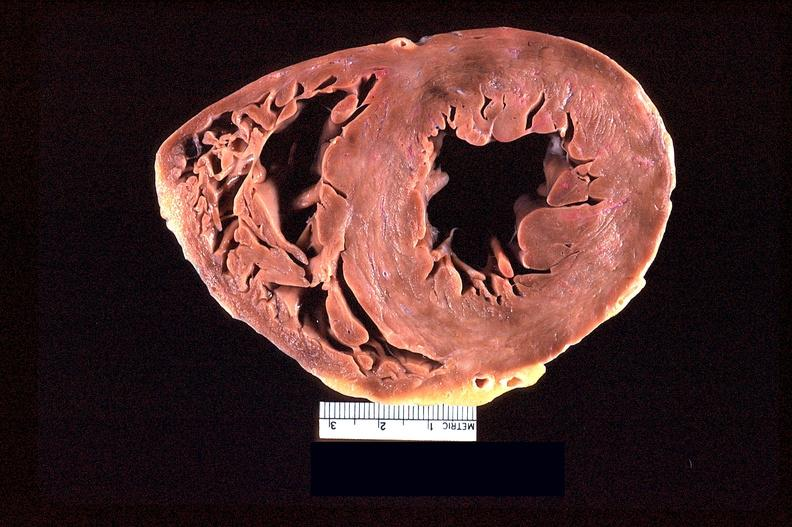where is this?
Answer the question using a single word or phrase. Heart 